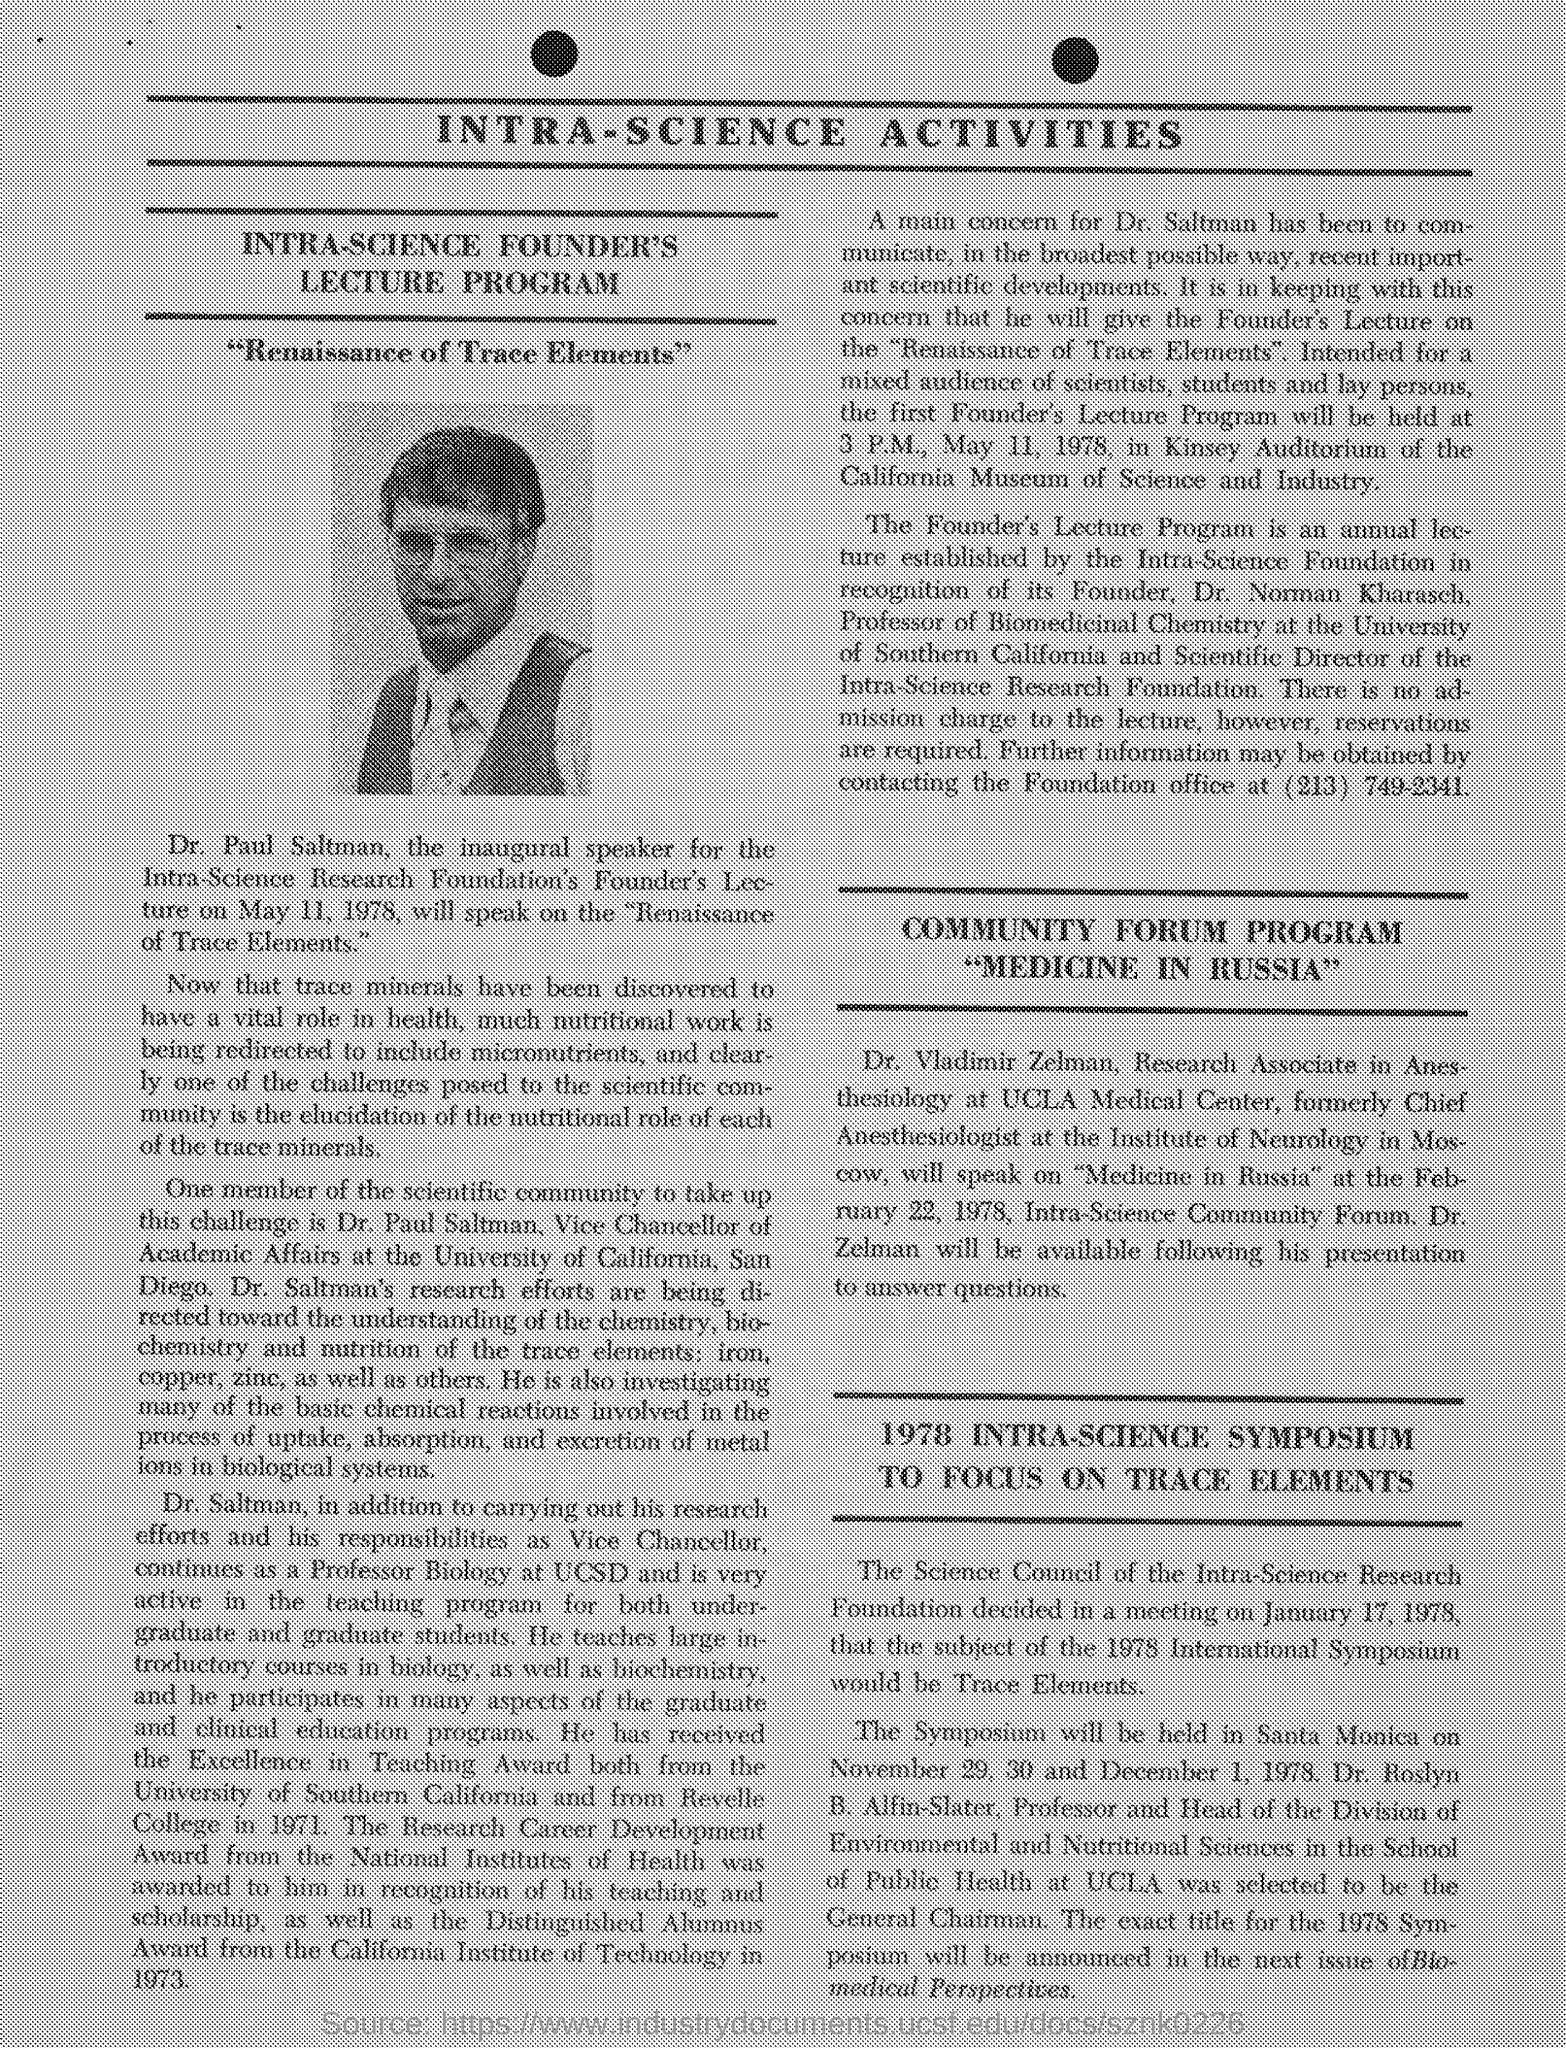Specify some key components in this picture. It has been announced that Dr. Paul Saltman will be speaking on the topic of "The Renaissance of Trace Elements. The document shows a photograph of Dr. Paul Saltman. Dr. Norman Kharasch is the founder of Intra-science foundation. The symposium is being held in Santa Monica. The inaugural speaker is Dr. Saltman. 